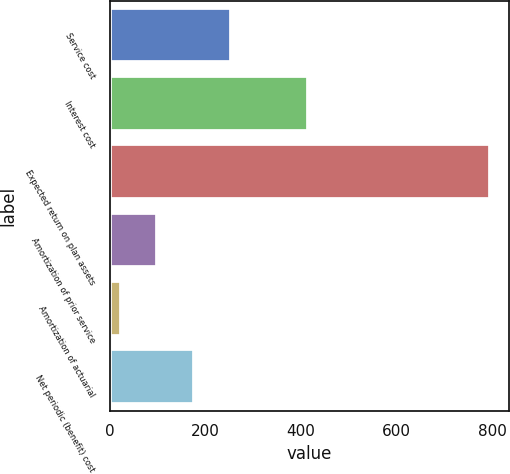Convert chart. <chart><loc_0><loc_0><loc_500><loc_500><bar_chart><fcel>Service cost<fcel>Interest cost<fcel>Expected return on plan assets<fcel>Amortization of prior service<fcel>Amortization of actuarial<fcel>Net periodic (benefit) cost<nl><fcel>254.9<fcel>415<fcel>796<fcel>100.3<fcel>23<fcel>177.6<nl></chart> 